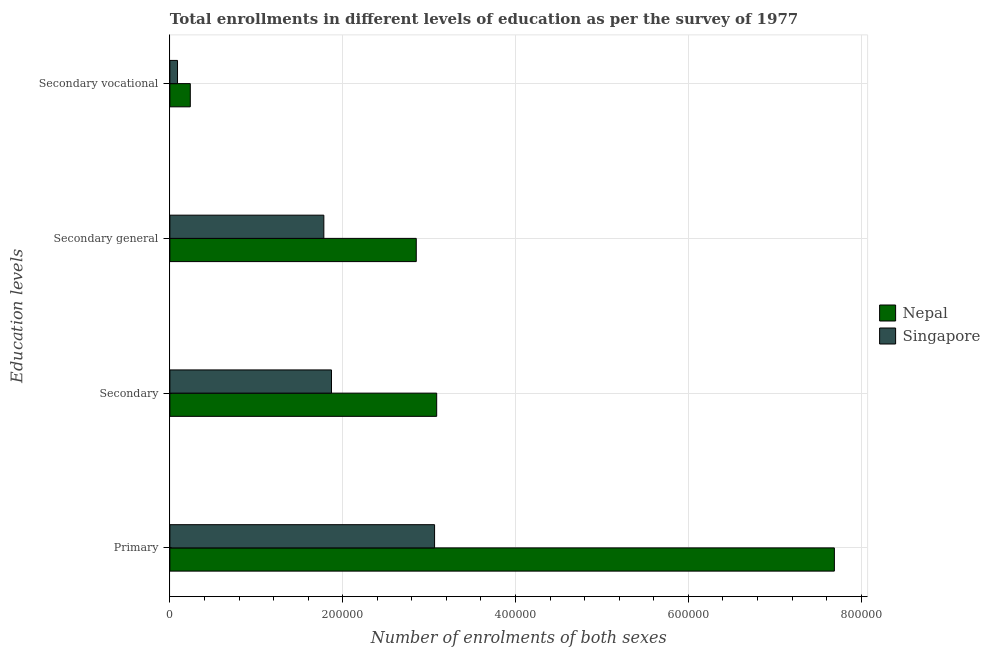How many different coloured bars are there?
Give a very brief answer. 2. Are the number of bars per tick equal to the number of legend labels?
Ensure brevity in your answer.  Yes. Are the number of bars on each tick of the Y-axis equal?
Offer a very short reply. Yes. How many bars are there on the 1st tick from the top?
Offer a terse response. 2. How many bars are there on the 4th tick from the bottom?
Provide a succinct answer. 2. What is the label of the 4th group of bars from the top?
Your answer should be compact. Primary. What is the number of enrolments in secondary general education in Singapore?
Offer a very short reply. 1.78e+05. Across all countries, what is the maximum number of enrolments in secondary education?
Your answer should be very brief. 3.09e+05. Across all countries, what is the minimum number of enrolments in secondary education?
Provide a succinct answer. 1.87e+05. In which country was the number of enrolments in secondary general education maximum?
Your answer should be compact. Nepal. In which country was the number of enrolments in primary education minimum?
Your answer should be very brief. Singapore. What is the total number of enrolments in secondary education in the graph?
Ensure brevity in your answer.  4.96e+05. What is the difference between the number of enrolments in secondary education in Singapore and that in Nepal?
Your response must be concise. -1.22e+05. What is the difference between the number of enrolments in secondary vocational education in Singapore and the number of enrolments in secondary education in Nepal?
Offer a terse response. -3.00e+05. What is the average number of enrolments in primary education per country?
Ensure brevity in your answer.  5.38e+05. What is the difference between the number of enrolments in secondary general education and number of enrolments in secondary vocational education in Nepal?
Offer a very short reply. 2.62e+05. What is the ratio of the number of enrolments in secondary general education in Nepal to that in Singapore?
Offer a very short reply. 1.6. What is the difference between the highest and the second highest number of enrolments in secondary general education?
Keep it short and to the point. 1.07e+05. What is the difference between the highest and the lowest number of enrolments in secondary education?
Your answer should be compact. 1.22e+05. In how many countries, is the number of enrolments in primary education greater than the average number of enrolments in primary education taken over all countries?
Give a very brief answer. 1. Is the sum of the number of enrolments in primary education in Singapore and Nepal greater than the maximum number of enrolments in secondary education across all countries?
Offer a terse response. Yes. Is it the case that in every country, the sum of the number of enrolments in secondary education and number of enrolments in primary education is greater than the sum of number of enrolments in secondary general education and number of enrolments in secondary vocational education?
Your answer should be compact. Yes. What does the 2nd bar from the top in Secondary represents?
Offer a very short reply. Nepal. What does the 1st bar from the bottom in Secondary general represents?
Your answer should be very brief. Nepal. Is it the case that in every country, the sum of the number of enrolments in primary education and number of enrolments in secondary education is greater than the number of enrolments in secondary general education?
Make the answer very short. Yes. How many countries are there in the graph?
Offer a very short reply. 2. What is the difference between two consecutive major ticks on the X-axis?
Provide a succinct answer. 2.00e+05. Does the graph contain grids?
Offer a very short reply. Yes. Where does the legend appear in the graph?
Make the answer very short. Center right. What is the title of the graph?
Keep it short and to the point. Total enrollments in different levels of education as per the survey of 1977. Does "St. Vincent and the Grenadines" appear as one of the legend labels in the graph?
Your answer should be compact. No. What is the label or title of the X-axis?
Your response must be concise. Number of enrolments of both sexes. What is the label or title of the Y-axis?
Your answer should be very brief. Education levels. What is the Number of enrolments of both sexes of Nepal in Primary?
Ensure brevity in your answer.  7.69e+05. What is the Number of enrolments of both sexes in Singapore in Primary?
Your answer should be compact. 3.06e+05. What is the Number of enrolments of both sexes in Nepal in Secondary?
Your answer should be very brief. 3.09e+05. What is the Number of enrolments of both sexes of Singapore in Secondary?
Offer a very short reply. 1.87e+05. What is the Number of enrolments of both sexes of Nepal in Secondary general?
Offer a very short reply. 2.85e+05. What is the Number of enrolments of both sexes of Singapore in Secondary general?
Your response must be concise. 1.78e+05. What is the Number of enrolments of both sexes in Nepal in Secondary vocational?
Offer a terse response. 2.36e+04. What is the Number of enrolments of both sexes of Singapore in Secondary vocational?
Ensure brevity in your answer.  8848. Across all Education levels, what is the maximum Number of enrolments of both sexes of Nepal?
Your answer should be very brief. 7.69e+05. Across all Education levels, what is the maximum Number of enrolments of both sexes in Singapore?
Ensure brevity in your answer.  3.06e+05. Across all Education levels, what is the minimum Number of enrolments of both sexes in Nepal?
Offer a terse response. 2.36e+04. Across all Education levels, what is the minimum Number of enrolments of both sexes in Singapore?
Your response must be concise. 8848. What is the total Number of enrolments of both sexes of Nepal in the graph?
Make the answer very short. 1.39e+06. What is the total Number of enrolments of both sexes in Singapore in the graph?
Offer a terse response. 6.80e+05. What is the difference between the Number of enrolments of both sexes in Nepal in Primary and that in Secondary?
Ensure brevity in your answer.  4.60e+05. What is the difference between the Number of enrolments of both sexes in Singapore in Primary and that in Secondary?
Give a very brief answer. 1.19e+05. What is the difference between the Number of enrolments of both sexes of Nepal in Primary and that in Secondary general?
Your answer should be very brief. 4.84e+05. What is the difference between the Number of enrolments of both sexes in Singapore in Primary and that in Secondary general?
Give a very brief answer. 1.28e+05. What is the difference between the Number of enrolments of both sexes of Nepal in Primary and that in Secondary vocational?
Your response must be concise. 7.45e+05. What is the difference between the Number of enrolments of both sexes of Singapore in Primary and that in Secondary vocational?
Offer a terse response. 2.98e+05. What is the difference between the Number of enrolments of both sexes of Nepal in Secondary and that in Secondary general?
Your response must be concise. 2.36e+04. What is the difference between the Number of enrolments of both sexes in Singapore in Secondary and that in Secondary general?
Your response must be concise. 8848. What is the difference between the Number of enrolments of both sexes of Nepal in Secondary and that in Secondary vocational?
Your answer should be very brief. 2.85e+05. What is the difference between the Number of enrolments of both sexes in Singapore in Secondary and that in Secondary vocational?
Offer a very short reply. 1.78e+05. What is the difference between the Number of enrolments of both sexes in Nepal in Secondary general and that in Secondary vocational?
Provide a succinct answer. 2.62e+05. What is the difference between the Number of enrolments of both sexes of Singapore in Secondary general and that in Secondary vocational?
Provide a short and direct response. 1.69e+05. What is the difference between the Number of enrolments of both sexes of Nepal in Primary and the Number of enrolments of both sexes of Singapore in Secondary?
Ensure brevity in your answer.  5.82e+05. What is the difference between the Number of enrolments of both sexes in Nepal in Primary and the Number of enrolments of both sexes in Singapore in Secondary general?
Give a very brief answer. 5.91e+05. What is the difference between the Number of enrolments of both sexes of Nepal in Primary and the Number of enrolments of both sexes of Singapore in Secondary vocational?
Keep it short and to the point. 7.60e+05. What is the difference between the Number of enrolments of both sexes in Nepal in Secondary and the Number of enrolments of both sexes in Singapore in Secondary general?
Provide a short and direct response. 1.31e+05. What is the difference between the Number of enrolments of both sexes in Nepal in Secondary and the Number of enrolments of both sexes in Singapore in Secondary vocational?
Your answer should be very brief. 3.00e+05. What is the difference between the Number of enrolments of both sexes in Nepal in Secondary general and the Number of enrolments of both sexes in Singapore in Secondary vocational?
Your answer should be compact. 2.76e+05. What is the average Number of enrolments of both sexes of Nepal per Education levels?
Provide a short and direct response. 3.47e+05. What is the average Number of enrolments of both sexes in Singapore per Education levels?
Ensure brevity in your answer.  1.70e+05. What is the difference between the Number of enrolments of both sexes of Nepal and Number of enrolments of both sexes of Singapore in Primary?
Offer a very short reply. 4.63e+05. What is the difference between the Number of enrolments of both sexes in Nepal and Number of enrolments of both sexes in Singapore in Secondary?
Your answer should be very brief. 1.22e+05. What is the difference between the Number of enrolments of both sexes in Nepal and Number of enrolments of both sexes in Singapore in Secondary general?
Ensure brevity in your answer.  1.07e+05. What is the difference between the Number of enrolments of both sexes in Nepal and Number of enrolments of both sexes in Singapore in Secondary vocational?
Ensure brevity in your answer.  1.48e+04. What is the ratio of the Number of enrolments of both sexes of Nepal in Primary to that in Secondary?
Ensure brevity in your answer.  2.49. What is the ratio of the Number of enrolments of both sexes of Singapore in Primary to that in Secondary?
Offer a very short reply. 1.64. What is the ratio of the Number of enrolments of both sexes in Nepal in Primary to that in Secondary general?
Keep it short and to the point. 2.7. What is the ratio of the Number of enrolments of both sexes in Singapore in Primary to that in Secondary general?
Provide a succinct answer. 1.72. What is the ratio of the Number of enrolments of both sexes of Nepal in Primary to that in Secondary vocational?
Keep it short and to the point. 32.53. What is the ratio of the Number of enrolments of both sexes of Singapore in Primary to that in Secondary vocational?
Offer a very short reply. 34.62. What is the ratio of the Number of enrolments of both sexes of Nepal in Secondary to that in Secondary general?
Provide a short and direct response. 1.08. What is the ratio of the Number of enrolments of both sexes in Singapore in Secondary to that in Secondary general?
Make the answer very short. 1.05. What is the ratio of the Number of enrolments of both sexes in Nepal in Secondary to that in Secondary vocational?
Your answer should be compact. 13.06. What is the ratio of the Number of enrolments of both sexes in Singapore in Secondary to that in Secondary vocational?
Offer a very short reply. 21.14. What is the ratio of the Number of enrolments of both sexes in Nepal in Secondary general to that in Secondary vocational?
Your answer should be very brief. 12.06. What is the ratio of the Number of enrolments of both sexes in Singapore in Secondary general to that in Secondary vocational?
Give a very brief answer. 20.14. What is the difference between the highest and the second highest Number of enrolments of both sexes in Nepal?
Your answer should be very brief. 4.60e+05. What is the difference between the highest and the second highest Number of enrolments of both sexes in Singapore?
Make the answer very short. 1.19e+05. What is the difference between the highest and the lowest Number of enrolments of both sexes of Nepal?
Offer a very short reply. 7.45e+05. What is the difference between the highest and the lowest Number of enrolments of both sexes in Singapore?
Give a very brief answer. 2.98e+05. 